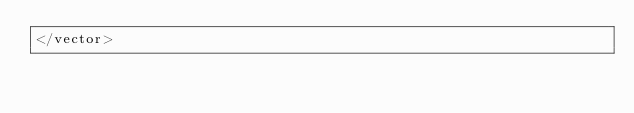<code> <loc_0><loc_0><loc_500><loc_500><_XML_></vector>
</code> 